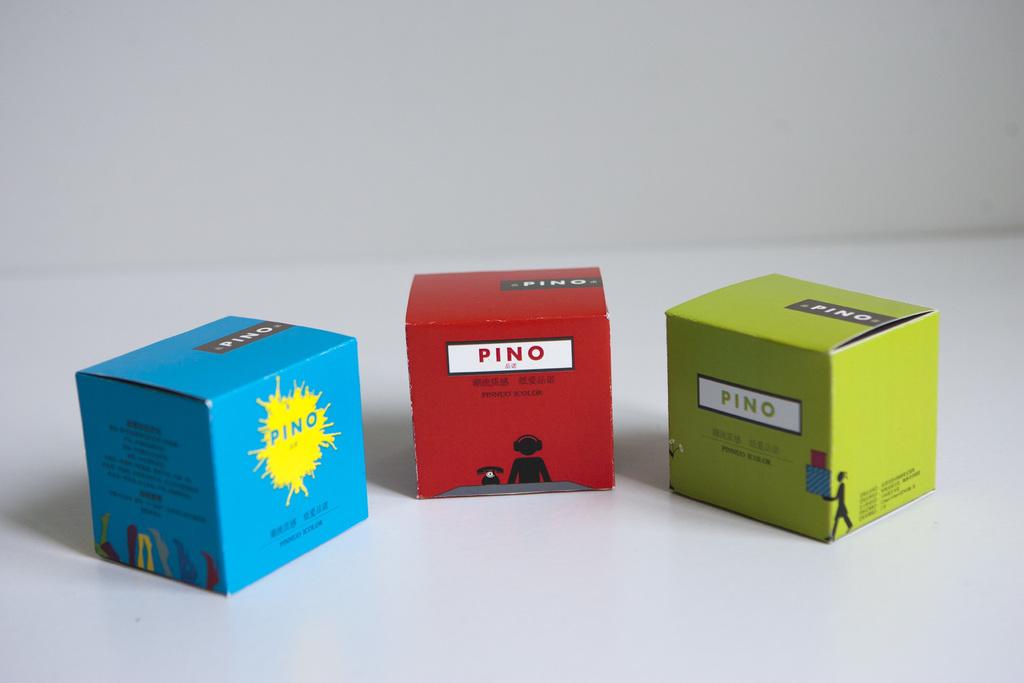What is the brand in the blue box?
Keep it short and to the point. Pino. What brand are these boxes?
Your response must be concise. Pino. 